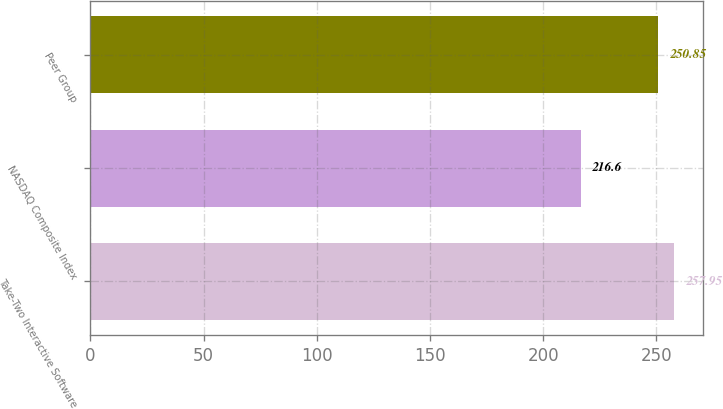Convert chart to OTSL. <chart><loc_0><loc_0><loc_500><loc_500><bar_chart><fcel>Take-Two Interactive Software<fcel>NASDAQ Composite Index<fcel>Peer Group<nl><fcel>257.95<fcel>216.6<fcel>250.85<nl></chart> 